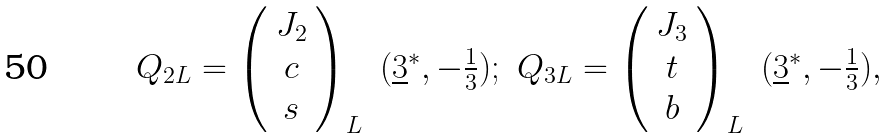<formula> <loc_0><loc_0><loc_500><loc_500>\begin{array} { c c c c } { { Q _ { 2 L } = \left ( \begin{array} { c } { { J _ { 2 } } } \\ { c } \\ { s } \end{array} \right ) _ { L } } } & { { ( \underline { 3 } ^ { * } , - \frac { 1 } { 3 } ) ; } } & { { Q _ { 3 L } = \left ( \begin{array} { c } { { J _ { 3 } } } \\ { t } \\ { b } \end{array} \right ) _ { L } } } & { { ( \underline { 3 } ^ { * } , - \frac { 1 } { 3 } ) , } } \end{array}</formula> 